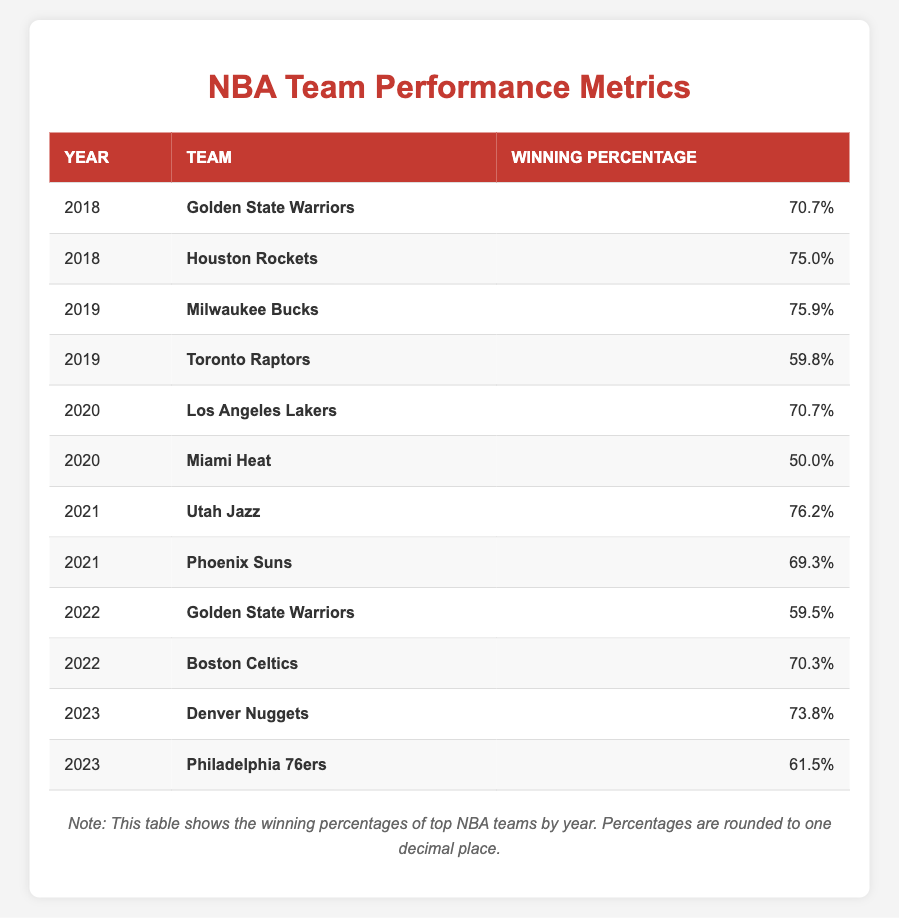What was the winning percentage of the Golden State Warriors in 2022? The table shows that in 2022, the Golden State Warriors had a winning percentage of 59.5%.
Answer: 59.5% Which team had the highest winning percentage in 2019? According to the table, the Milwaukee Bucks had the highest winning percentage in 2019, with 75.9%.
Answer: 75.9% Did the Miami Heat have a winning percentage above 50% in 2020? The table shows that the Miami Heat had a winning percentage of 50.0% in 2020, which is not above 50%.
Answer: No What is the average winning percentage of the teams in 2021? The winning percentages for teams in 2021 are 76.2% (Utah Jazz) and 69.3% (Phoenix Suns). The sum is 76.2 + 69.3 = 145.5, and there are 2 teams, so the average is 145.5 / 2 = 72.75%.
Answer: 72.75% Which team had a winning percentage of 70.7% in multiple years? The table reveals that both the Los Angeles Lakers in 2020 and the Golden State Warriors in 2018 had a winning percentage of 70.7%.
Answer: Golden State Warriors, Los Angeles Lakers What was the winning percentage of the Philadelphia 76ers in 2023? The table indicates that the Philadelphia 76ers had a winning percentage of 61.5% in 2023.
Answer: 61.5% Was there a team with a winning percentage lower than 60% in 2022? The table shows that the Golden State Warriors had a winning percentage of 59.5%, which is indeed lower than 60%.
Answer: Yes What is the difference in winning percentages between the top team and the lowest team for the year 2023? For 2023, the Denver Nuggets had the highest winning percentage at 73.8% and the Philadelphia 76ers had 61.5%. The difference is 73.8 - 61.5 = 12.3%.
Answer: 12.3% 